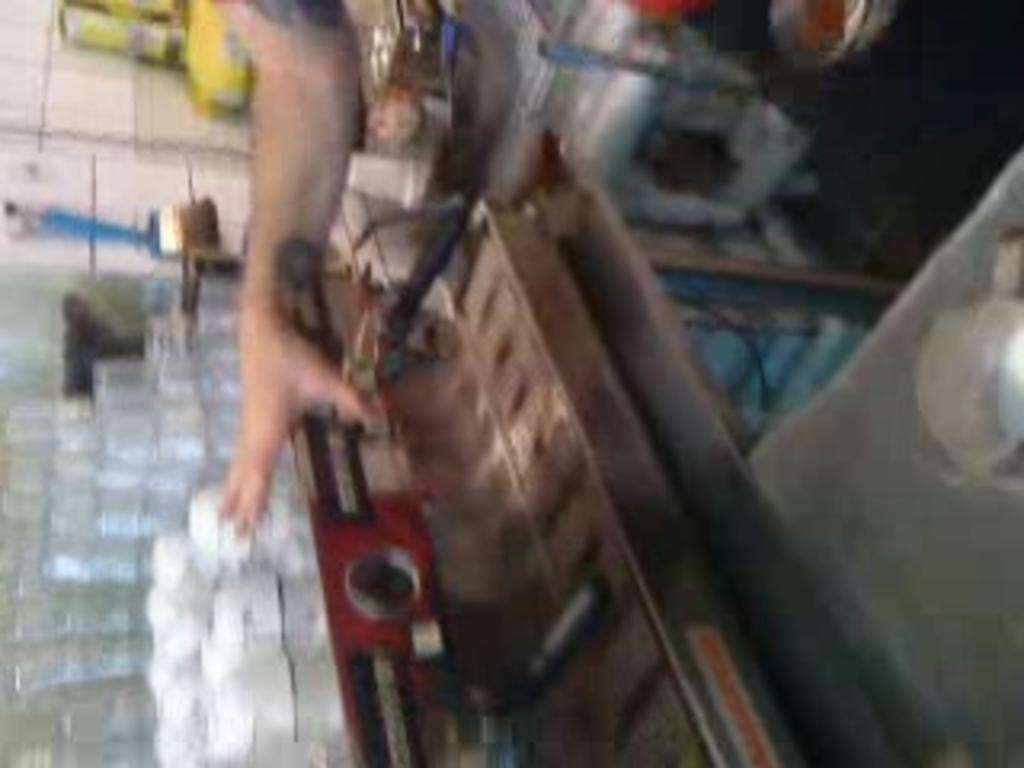What is the main object in the image? There is a table in the image. What is on the table? There are products on the table. Can you describe any other visible elements in the image? A hand is visible at the top of the image. How would you describe the background of the image? The background of the image is blurred. What type of insurance policy is being discussed by the owl in the image? There is no owl present in the image, so it is not possible to discuss any insurance policy with an owl. 